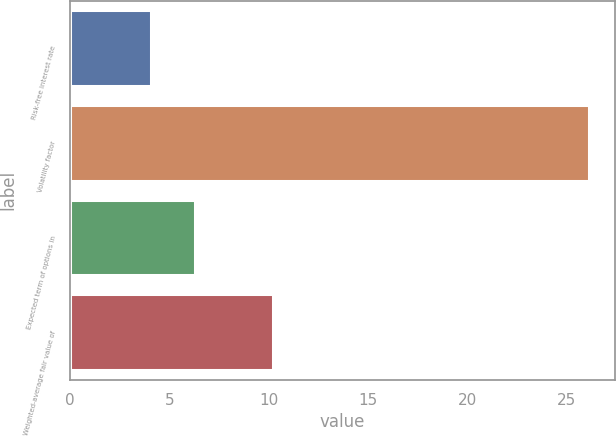Convert chart to OTSL. <chart><loc_0><loc_0><loc_500><loc_500><bar_chart><fcel>Risk-free interest rate<fcel>Volatility factor<fcel>Expected term of options in<fcel>Weighted-average fair value of<nl><fcel>4.09<fcel>26.1<fcel>6.29<fcel>10.22<nl></chart> 